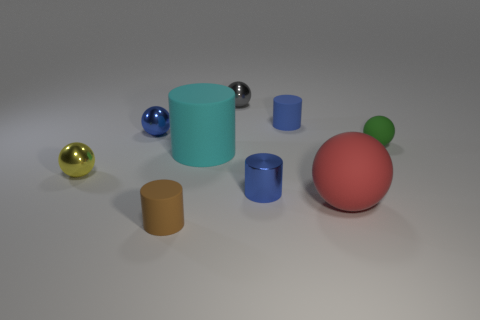There is a object that is to the left of the cyan object and to the right of the small blue ball; what is its shape?
Give a very brief answer. Cylinder. There is a blue metallic object behind the small yellow metallic object; does it have the same size as the matte ball that is in front of the large cyan rubber object?
Make the answer very short. No. What is the shape of the tiny brown object that is made of the same material as the large red sphere?
Keep it short and to the point. Cylinder. What is the color of the large rubber thing behind the tiny metallic ball that is in front of the tiny ball that is right of the gray thing?
Give a very brief answer. Cyan. Is the number of blue rubber things that are on the left side of the blue ball less than the number of matte things that are behind the small gray object?
Give a very brief answer. No. Is the red thing the same shape as the small gray thing?
Give a very brief answer. Yes. What number of purple matte cylinders are the same size as the brown object?
Your answer should be compact. 0. Is the number of small blue rubber cylinders in front of the blue metallic ball less than the number of brown blocks?
Offer a terse response. No. What size is the rubber ball that is in front of the big rubber object left of the gray ball?
Provide a short and direct response. Large. How many things are either gray metallic things or cyan objects?
Provide a succinct answer. 2. 